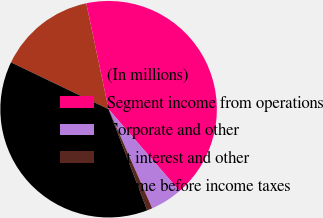Convert chart to OTSL. <chart><loc_0><loc_0><loc_500><loc_500><pie_chart><fcel>(In millions)<fcel>Segment income from operations<fcel>Corporate and other<fcel>Net interest and other<fcel>Income before income taxes<nl><fcel>14.57%<fcel>41.93%<fcel>4.78%<fcel>0.79%<fcel>37.93%<nl></chart> 